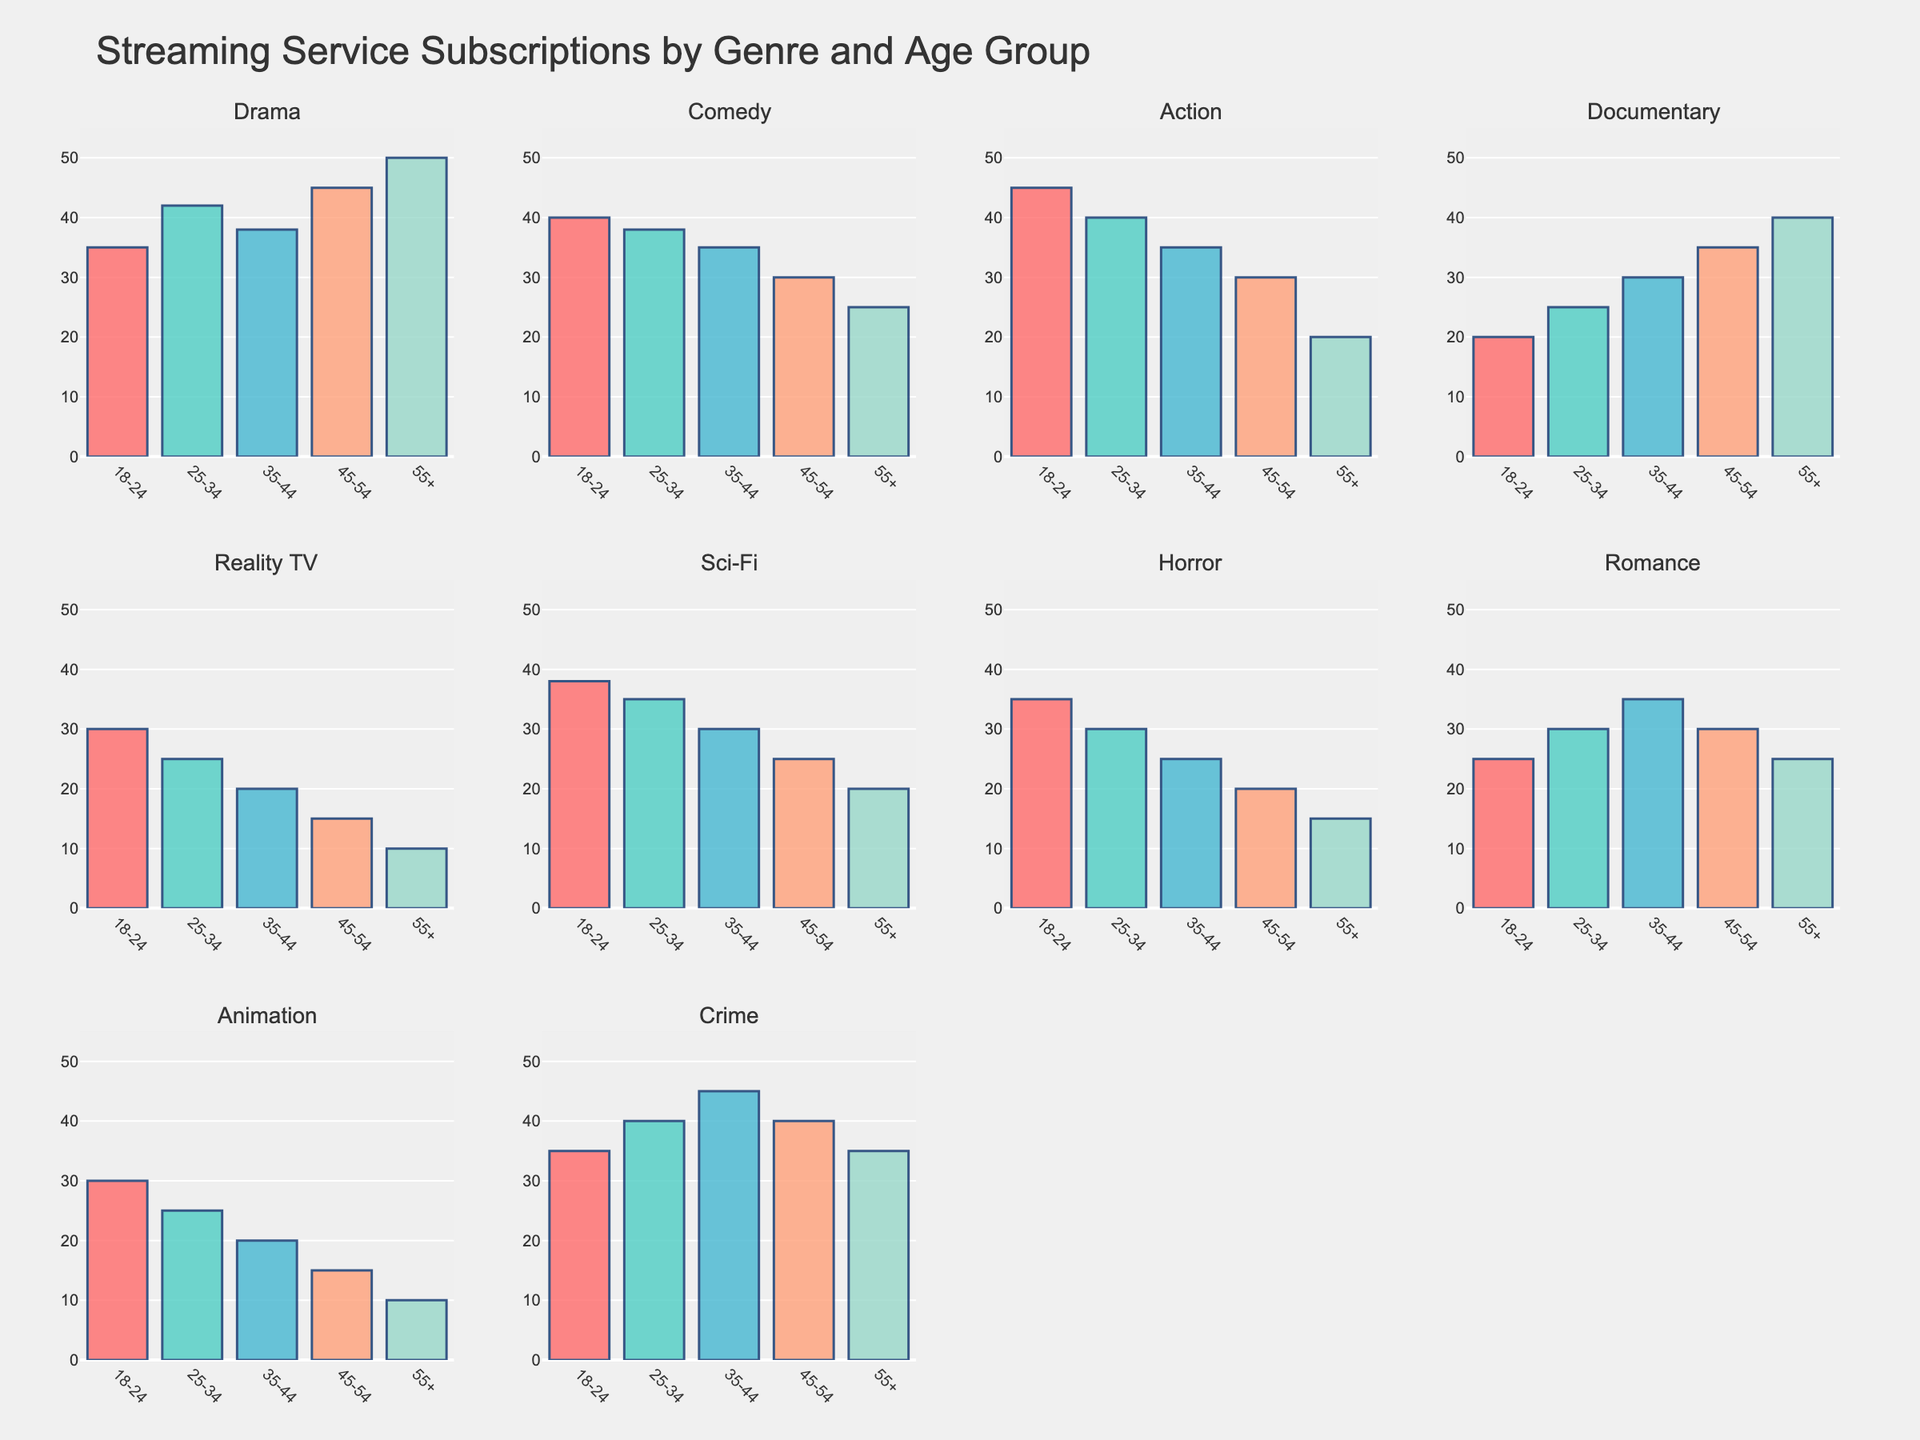How many genres are plotted in the figure? The figure has 3 rows and 4 columns of subplots, totaling 3 x 4 = 12 subplots. Therefore, 12 genres are plotted.
Answer: 12 What is the highest value on the y-axis? Each subplot's y-axis ranges from 0 to 55, with the highest value labeled as 55.
Answer: 55 Which age group prefers Comedy the most? In the Comedy subplot, the bar for the 18-24 age group reaches the highest value compared to other age groups, indicating they prefer Comedy the most.
Answer: 18-24 Which genre is least preferred by the 55+ age group? For the 55+ age group, the bar for Reality TV and Animation subplots is the lowest, both values being 10.
Answer: Reality TV, Animation What is the average subscription rate for Drama across all age groups? The subscription rates for Drama are 35, 42, 38, 45, and 50. Adding these values gives 210, and dividing by 5 age groups gives the average: 210 / 5 = 42.
Answer: 42 In which genre does the preference decrease monotonically with increasing age? In the Action subplot, the values decrease steadily with each increasing age group: 45, 40, 35, 30, 20. Hence, the preference for Action decreases monotonically with age.
Answer: Action Which two genres have the same subscription rate for the 25-34 age group? Both Sci-Fi and Romance subplots show a subscription rate of 35 for the 25-34 age group.
Answer: Sci-Fi, Romance Compare the preference for Horror between the 18-24 and 55+ age groups. Which has a higher value and by how much? The 18-24 age group has a subscription rate of 35, and the 55+ age group has a rate of 15 for Horror. The difference is 35 - 15 = 20, so the 18-24 age group has a higher value by 20.
Answer: 18-24, 20 What is the total subscription rate for Documentary for all age groups combined? The subscription rates for Documentary are 20, 25, 30, 35, and 40. Summing these values gives 20 + 25 + 30 + 35 + 40 = 150.
Answer: 150 Which genre shows the most variation in subscription rates among age groups? To find the most variation, compare the difference between the highest and lowest subscription rates in each genre. For example, Drama ranges from 35 to 50, Comedy from 25 to 40, etc. Action shows the most variation ranging from 20 to 45, a variation of 25.
Answer: Action 